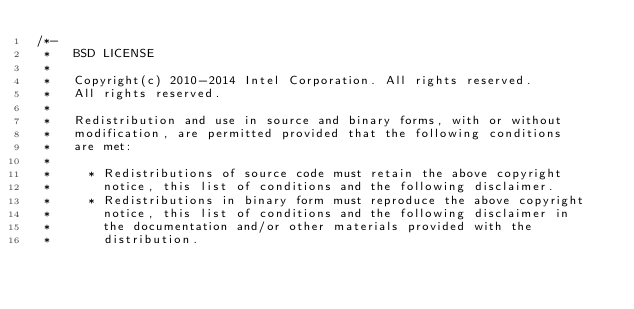Convert code to text. <code><loc_0><loc_0><loc_500><loc_500><_C_>/*-
 *   BSD LICENSE
 *
 *   Copyright(c) 2010-2014 Intel Corporation. All rights reserved.
 *   All rights reserved.
 *
 *   Redistribution and use in source and binary forms, with or without
 *   modification, are permitted provided that the following conditions
 *   are met:
 *
 *     * Redistributions of source code must retain the above copyright
 *       notice, this list of conditions and the following disclaimer.
 *     * Redistributions in binary form must reproduce the above copyright
 *       notice, this list of conditions and the following disclaimer in
 *       the documentation and/or other materials provided with the
 *       distribution.</code> 